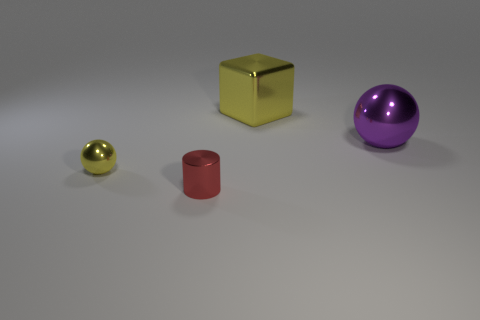Is there a small yellow ball behind the small thing behind the tiny shiny cylinder?
Offer a very short reply. No. What number of things are tiny gray rubber cubes or tiny red metallic things?
Give a very brief answer. 1. The metallic object that is both right of the red shiny cylinder and in front of the large yellow block has what shape?
Give a very brief answer. Sphere. Do the small red object on the left side of the purple shiny thing and the purple object have the same material?
Offer a very short reply. Yes. What number of things are either tiny metal cylinders or things left of the big purple metal sphere?
Your answer should be compact. 3. There is a cube that is made of the same material as the purple thing; what color is it?
Your response must be concise. Yellow. What number of big purple spheres are made of the same material as the cube?
Provide a succinct answer. 1. What number of tiny cyan objects are there?
Provide a succinct answer. 0. There is a object that is left of the tiny red metallic thing; does it have the same color as the shiny object behind the purple ball?
Your answer should be compact. Yes. There is a small red cylinder; what number of red metal objects are behind it?
Your answer should be compact. 0. 